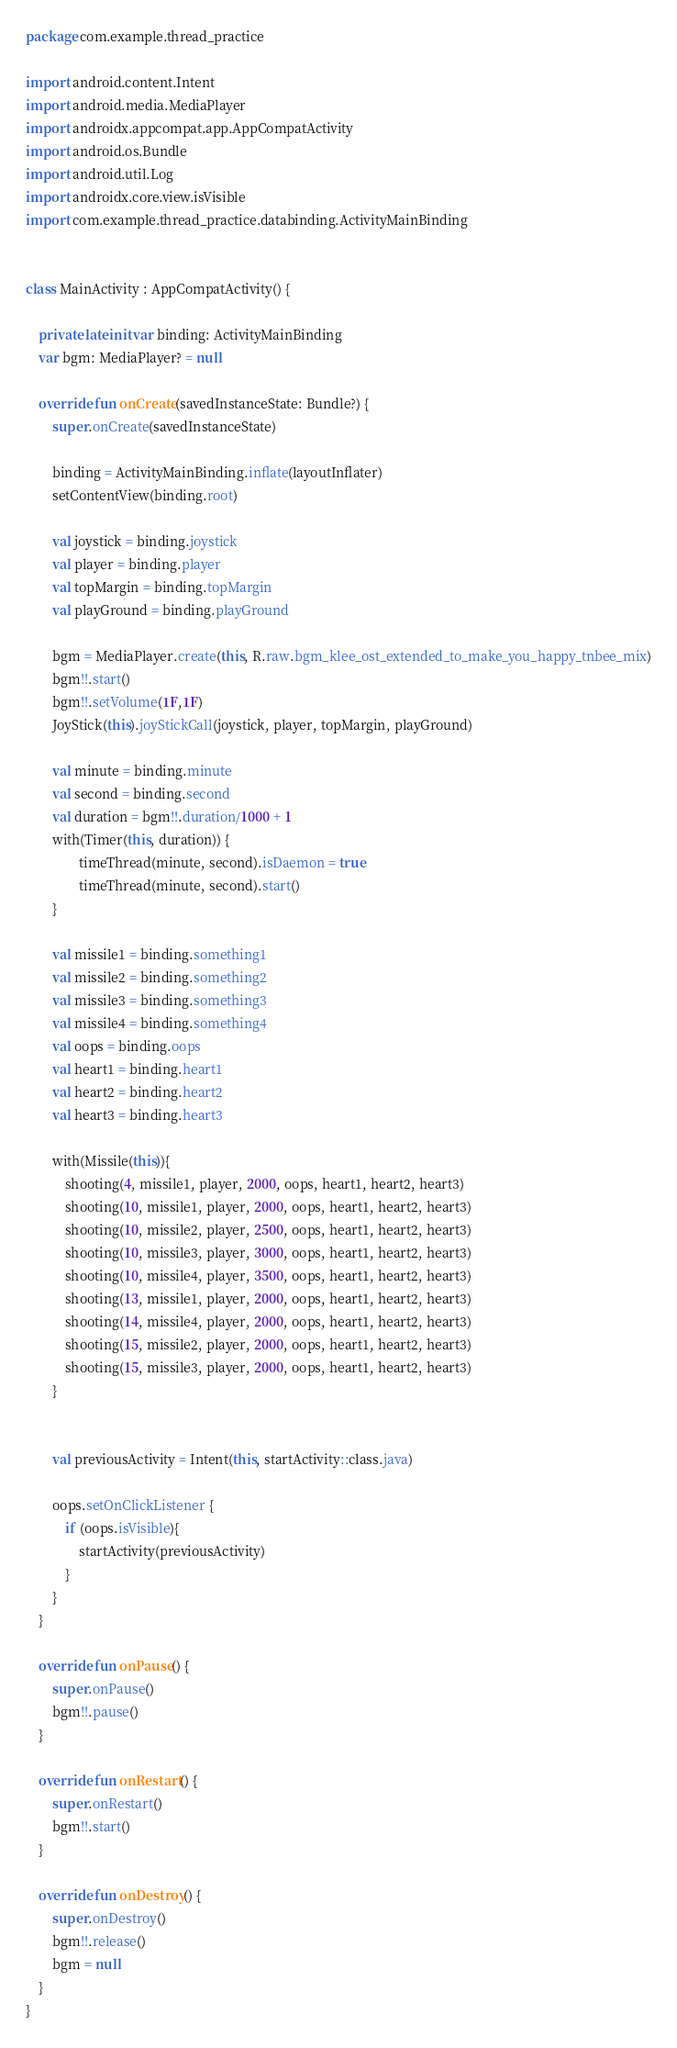Convert code to text. <code><loc_0><loc_0><loc_500><loc_500><_Kotlin_>package com.example.thread_practice

import android.content.Intent
import android.media.MediaPlayer
import androidx.appcompat.app.AppCompatActivity
import android.os.Bundle
import android.util.Log
import androidx.core.view.isVisible
import com.example.thread_practice.databinding.ActivityMainBinding


class MainActivity : AppCompatActivity() {

    private lateinit var binding: ActivityMainBinding
    var bgm: MediaPlayer? = null

    override fun onCreate(savedInstanceState: Bundle?) {
        super.onCreate(savedInstanceState)

        binding = ActivityMainBinding.inflate(layoutInflater)
        setContentView(binding.root)

        val joystick = binding.joystick
        val player = binding.player
        val topMargin = binding.topMargin
        val playGround = binding.playGround

        bgm = MediaPlayer.create(this, R.raw.bgm_klee_ost_extended_to_make_you_happy_tnbee_mix)
        bgm!!.start()
        bgm!!.setVolume(1F,1F)
        JoyStick(this).joyStickCall(joystick, player, topMargin, playGround)

        val minute = binding.minute
        val second = binding.second
        val duration = bgm!!.duration/1000 + 1
        with(Timer(this, duration)) {
                timeThread(minute, second).isDaemon = true
                timeThread(minute, second).start()
        }

        val missile1 = binding.something1
        val missile2 = binding.something2
        val missile3 = binding.something3
        val missile4 = binding.something4
        val oops = binding.oops
        val heart1 = binding.heart1
        val heart2 = binding.heart2
        val heart3 = binding.heart3

        with(Missile(this)){
            shooting(4, missile1, player, 2000, oops, heart1, heart2, heart3)
            shooting(10, missile1, player, 2000, oops, heart1, heart2, heart3)
            shooting(10, missile2, player, 2500, oops, heart1, heart2, heart3)
            shooting(10, missile3, player, 3000, oops, heart1, heart2, heart3)
            shooting(10, missile4, player, 3500, oops, heart1, heart2, heart3)
            shooting(13, missile1, player, 2000, oops, heart1, heart2, heart3)
            shooting(14, missile4, player, 2000, oops, heart1, heart2, heart3)
            shooting(15, missile2, player, 2000, oops, heart1, heart2, heart3)
            shooting(15, missile3, player, 2000, oops, heart1, heart2, heart3)
        }


        val previousActivity = Intent(this, startActivity::class.java)

        oops.setOnClickListener {
            if (oops.isVisible){
                startActivity(previousActivity)
            }
        }
    }

    override fun onPause() {
        super.onPause()
        bgm!!.pause()
    }

    override fun onRestart() {
        super.onRestart()
        bgm!!.start()
    }

    override fun onDestroy() {
        super.onDestroy()
        bgm!!.release()
        bgm = null
    }
}</code> 